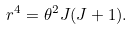<formula> <loc_0><loc_0><loc_500><loc_500>r ^ { 4 } = \theta ^ { 2 } J ( J + 1 ) .</formula> 